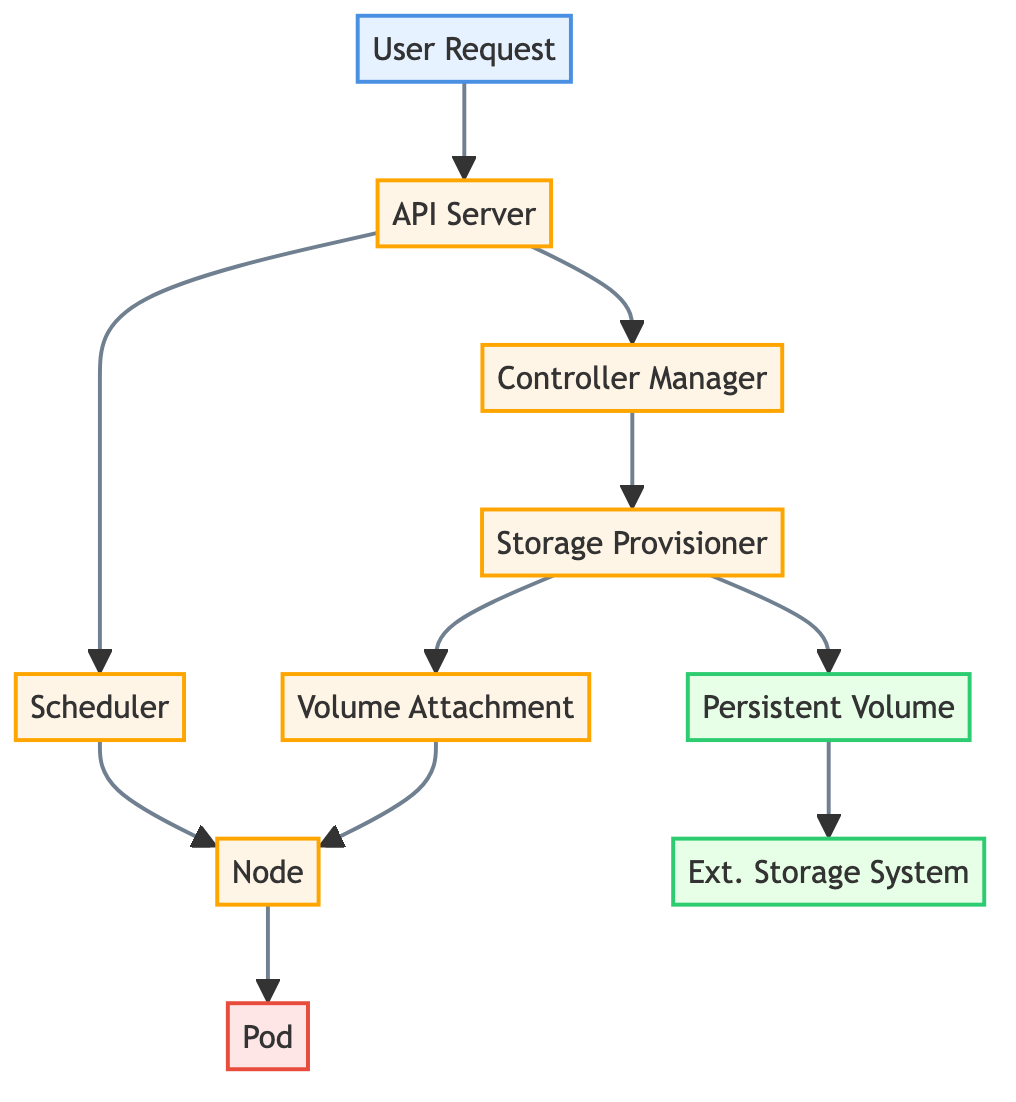What is the first element in the diagram? The first element in the diagram is labeled "User Request," which represents the initial storage request from the user.
Answer: User Request How many processes are present in the diagram? The diagram contains five processes: API Server, Scheduler, Controller Manager, Storage Provisioner, and Volume Attachment. Counting all the processes listed leads to this total.
Answer: 5 What is the relationship between the Controller Manager and the Storage Provisioner? The Controller Manager sends a request to the Storage Provisioner, as indicated by the arrow connecting them in the diagram, showing the flow of control in the process.
Answer: Flow of control Which storage component does the Storage Provisioner create? The Storage Provisioner creates a Persistent Volume, as indicated by their direct connection in the diagram.
Answer: Persistent Volume What component is responsible for attaching the provisioned storage to the node? The component responsible for this task is the Volume Attachment, which is connected to both the Storage Provisioner and the Node in the diagram.
Answer: Volume Attachment How does the Pod utilize the Persistent Volume? The Pod uses the Persistent Volume by creating a link from the Node to the Pod in the diagram, indicating data storage use.
Answer: Through the Node Which process handles user requests? The API Server handles user requests, as evidenced by the direct connection from the User Request to the API Server in the diagram.
Answer: API Server What element follows the Scheduler in the data flow? The element that follows the Scheduler in the data flow is the Node, which indicates the next step in processing storage requests after scheduling.
Answer: Node Which two storage components are represented in the diagram? The two storage components represented in the diagram are Persistent Volume and External Storage System, indicating the levels at which storage is managed and utilized.
Answer: Persistent Volume and External Storage System What indicates the flow of requests in the diagram? The arrows connecting the various elements indicate the flow of requests, showing how each component interacts and passes requests or data to the next.
Answer: Arrows 